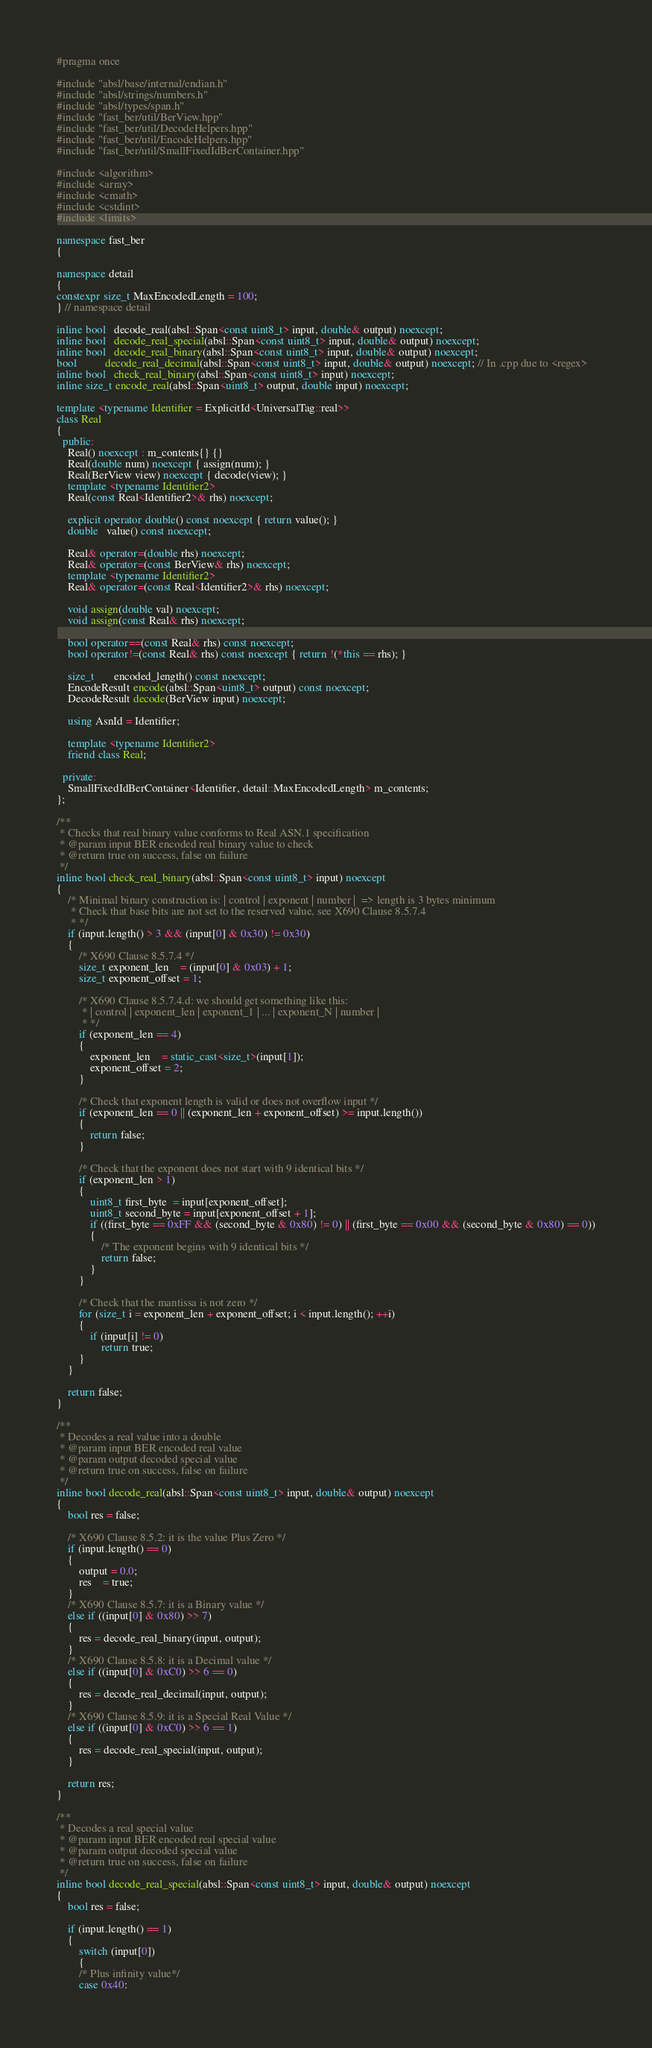<code> <loc_0><loc_0><loc_500><loc_500><_C++_>#pragma once

#include "absl/base/internal/endian.h"
#include "absl/strings/numbers.h"
#include "absl/types/span.h"
#include "fast_ber/util/BerView.hpp"
#include "fast_ber/util/DecodeHelpers.hpp"
#include "fast_ber/util/EncodeHelpers.hpp"
#include "fast_ber/util/SmallFixedIdBerContainer.hpp"

#include <algorithm>
#include <array>
#include <cmath>
#include <cstdint>
#include <limits>

namespace fast_ber
{

namespace detail
{
constexpr size_t MaxEncodedLength = 100;
} // namespace detail

inline bool   decode_real(absl::Span<const uint8_t> input, double& output) noexcept;
inline bool   decode_real_special(absl::Span<const uint8_t> input, double& output) noexcept;
inline bool   decode_real_binary(absl::Span<const uint8_t> input, double& output) noexcept;
bool          decode_real_decimal(absl::Span<const uint8_t> input, double& output) noexcept; // In .cpp due to <regex>
inline bool   check_real_binary(absl::Span<const uint8_t> input) noexcept;
inline size_t encode_real(absl::Span<uint8_t> output, double input) noexcept;

template <typename Identifier = ExplicitId<UniversalTag::real>>
class Real
{
  public:
    Real() noexcept : m_contents{} {}
    Real(double num) noexcept { assign(num); }
    Real(BerView view) noexcept { decode(view); }
    template <typename Identifier2>
    Real(const Real<Identifier2>& rhs) noexcept;

    explicit operator double() const noexcept { return value(); }
    double   value() const noexcept;

    Real& operator=(double rhs) noexcept;
    Real& operator=(const BerView& rhs) noexcept;
    template <typename Identifier2>
    Real& operator=(const Real<Identifier2>& rhs) noexcept;

    void assign(double val) noexcept;
    void assign(const Real& rhs) noexcept;

    bool operator==(const Real& rhs) const noexcept;
    bool operator!=(const Real& rhs) const noexcept { return !(*this == rhs); }

    size_t       encoded_length() const noexcept;
    EncodeResult encode(absl::Span<uint8_t> output) const noexcept;
    DecodeResult decode(BerView input) noexcept;

    using AsnId = Identifier;

    template <typename Identifier2>
    friend class Real;

  private:
    SmallFixedIdBerContainer<Identifier, detail::MaxEncodedLength> m_contents;
};

/**
 * Checks that real binary value conforms to Real ASN.1 specification
 * @param input BER encoded real binary value to check
 * @return true on success, false on failure
 */
inline bool check_real_binary(absl::Span<const uint8_t> input) noexcept
{
    /* Minimal binary construction is: | control | exponent | number |  => length is 3 bytes minimum
     * Check that base bits are not set to the reserved value, see X690 Clause 8.5.7.4
     * */
    if (input.length() > 3 && (input[0] & 0x30) != 0x30)
    {
        /* X690 Clause 8.5.7.4 */
        size_t exponent_len    = (input[0] & 0x03) + 1;
        size_t exponent_offset = 1;

        /* X690 Clause 8.5.7.4.d: we should get something like this:
         * | control | exponent_len | exponent_1 | ... | exponent_N | number |
         * */
        if (exponent_len == 4)
        {
            exponent_len    = static_cast<size_t>(input[1]);
            exponent_offset = 2;
        }

        /* Check that exponent length is valid or does not overflow input */
        if (exponent_len == 0 || (exponent_len + exponent_offset) >= input.length())
        {
            return false;
        }

        /* Check that the exponent does not start with 9 identical bits */
        if (exponent_len > 1)
        {
            uint8_t first_byte  = input[exponent_offset];
            uint8_t second_byte = input[exponent_offset + 1];
            if ((first_byte == 0xFF && (second_byte & 0x80) != 0) || (first_byte == 0x00 && (second_byte & 0x80) == 0))
            {
                /* The exponent begins with 9 identical bits */
                return false;
            }
        }

        /* Check that the mantissa is not zero */
        for (size_t i = exponent_len + exponent_offset; i < input.length(); ++i)
        {
            if (input[i] != 0)
                return true;
        }
    }

    return false;
}

/**
 * Decodes a real value into a double
 * @param input BER encoded real value
 * @param output decoded special value
 * @return true on success, false on failure
 */
inline bool decode_real(absl::Span<const uint8_t> input, double& output) noexcept
{
    bool res = false;

    /* X690 Clause 8.5.2: it is the value Plus Zero */
    if (input.length() == 0)
    {
        output = 0.0;
        res    = true;
    }
    /* X690 Clause 8.5.7: it is a Binary value */
    else if ((input[0] & 0x80) >> 7)
    {
        res = decode_real_binary(input, output);
    }
    /* X690 Clause 8.5.8: it is a Decimal value */
    else if ((input[0] & 0xC0) >> 6 == 0)
    {
        res = decode_real_decimal(input, output);
    }
    /* X690 Clause 8.5.9: it is a Special Real Value */
    else if ((input[0] & 0xC0) >> 6 == 1)
    {
        res = decode_real_special(input, output);
    }

    return res;
}

/**
 * Decodes a real special value
 * @param input BER encoded real special value
 * @param output decoded special value
 * @return true on success, false on failure
 */
inline bool decode_real_special(absl::Span<const uint8_t> input, double& output) noexcept
{
    bool res = false;

    if (input.length() == 1)
    {
        switch (input[0])
        {
        /* Plus infinity value*/
        case 0x40:</code> 